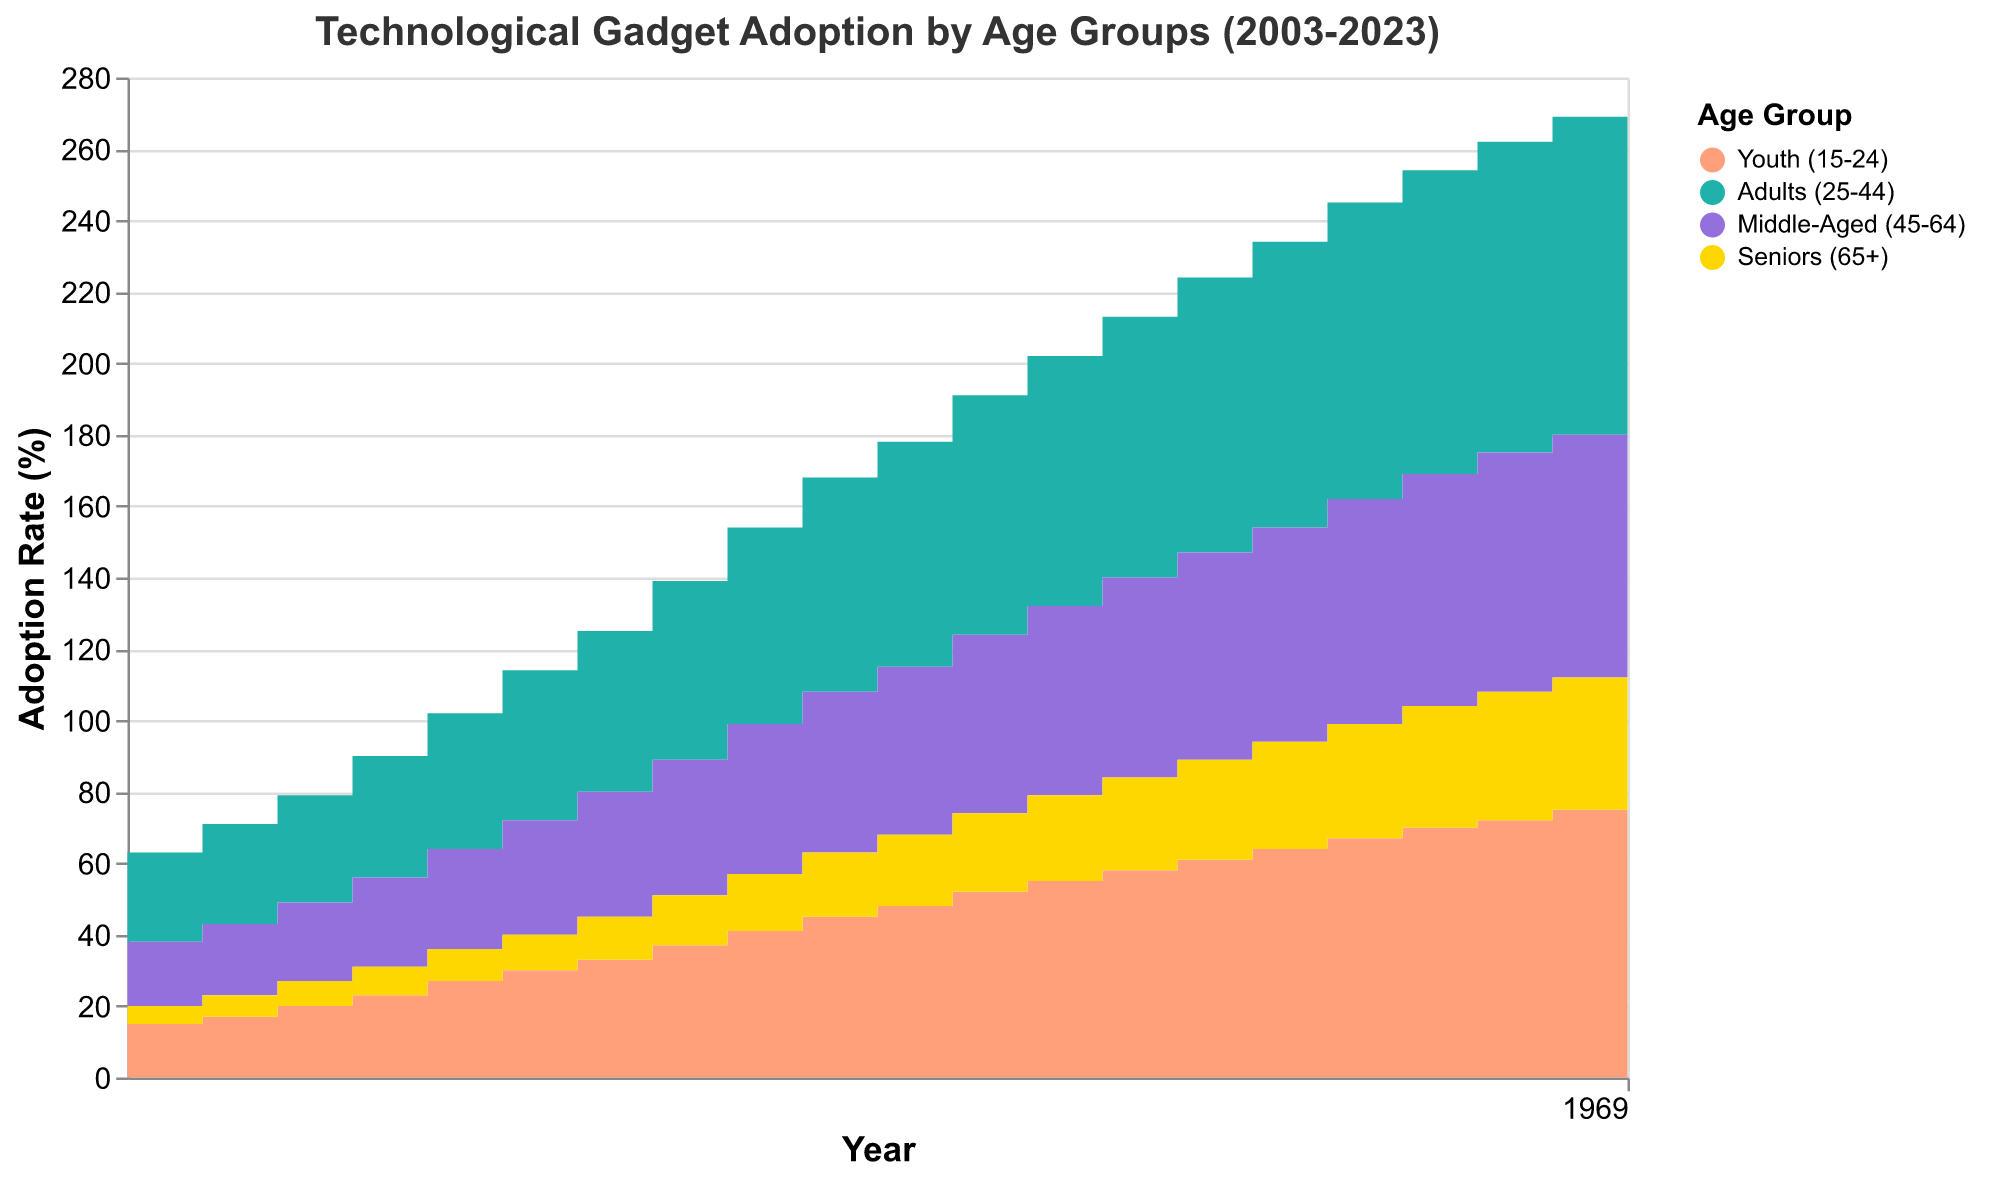What is the title of the chart? The title of the chart is located at the top and reads "Technological Gadget Adoption by Age Groups (2003-2023)."
Answer: Technological Gadget Adoption by Age Groups (2003-2023) In which year did the Youth (15-24) group first surpass a 50% adoption rate? Observing the area for the Youth (15-24) group, the adoption rate first surpasses 50% in the year 2014.
Answer: 2014 Which age group had the lowest adoption rate in 2023? By comparing the endpoint of each colored segment in the year 2023, the Seniors (65+) group has the lowest adoption rate.
Answer: Seniors (65+) What was the adoption rate for Adults (25-44) in 2018? The value for Adults (25-44) in the year 2018 is found within the greenish-turquoise area segment corresponding to the year 2018. The adoption rate is 80%.
Answer: 80% How much did the adoption rate for the Middle-Aged (45-64) group increase from 2003 to 2023? Subtract the starting value for Middle-Aged (45-64) in 2003 (18%) from the ending value in 2023 (70%). The increase is 70% - 18% = 52%.
Answer: 52% Which age group had the steadiest increase in their adoption rate over the years? By analyzing the slopes of each age group's area segment, the Adults (25-44) group maintains a relatively steady increase without large fluctuations over the years.
Answer: Adults (25-44) Between which consecutive years did the Seniors (65+) see the highest increase in adoption rate? By examining the area for Seniors (65+), it appears that the sharpest rise occurs between 2008 and 2009, where the rate jumps from 10% to 12%.
Answer: Between 2008 and 2009 What is the combined adoption rate of all age groups in 2020? To find the combined adoption rate for 2020, sum the values from each group: Youth (70%) + Adults (85%) + Middle-Aged (65%) + Seniors (34%) = 70 + 85 + 65 + 34 = 254%.
Answer: 254% How many age groups reached at least a 70% adoption rate by 2023? By checking the 2023 data points, the Youth (78%), Adults (90%), and Middle-Aged (70%) groups all surpass 70%. Therefore, 3 age groups reached at least 70%.
Answer: 3 What can be inferred about the trend of technological adoption in the Seniors (65+) group over the last 20 years? Observing the step area changes for the Seniors group, there's a consistent upward trend without any drops, indicating a continuous increase in adoption rates over the last 20 years.
Answer: Continuous increase 